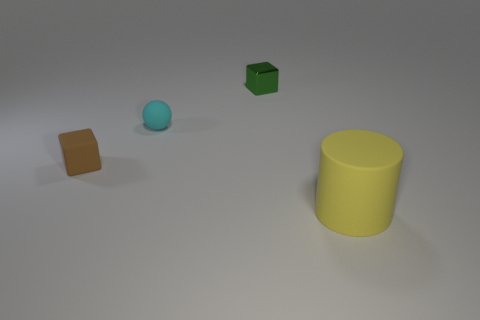Add 2 metal things. How many objects exist? 6 Subtract all brown cubes. How many cubes are left? 1 Subtract all balls. How many objects are left? 3 Subtract all blue cubes. Subtract all gray balls. How many cubes are left? 2 Subtract all tiny brown objects. Subtract all metal blocks. How many objects are left? 2 Add 3 metallic objects. How many metallic objects are left? 4 Add 3 small cyan objects. How many small cyan objects exist? 4 Subtract 0 purple balls. How many objects are left? 4 